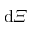Convert formula to latex. <formula><loc_0><loc_0><loc_500><loc_500>d \varXi</formula> 